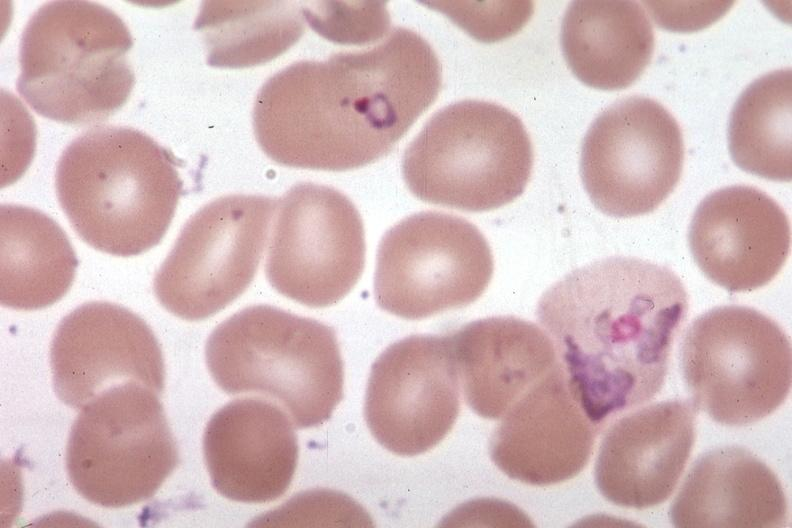s blood present?
Answer the question using a single word or phrase. Yes 